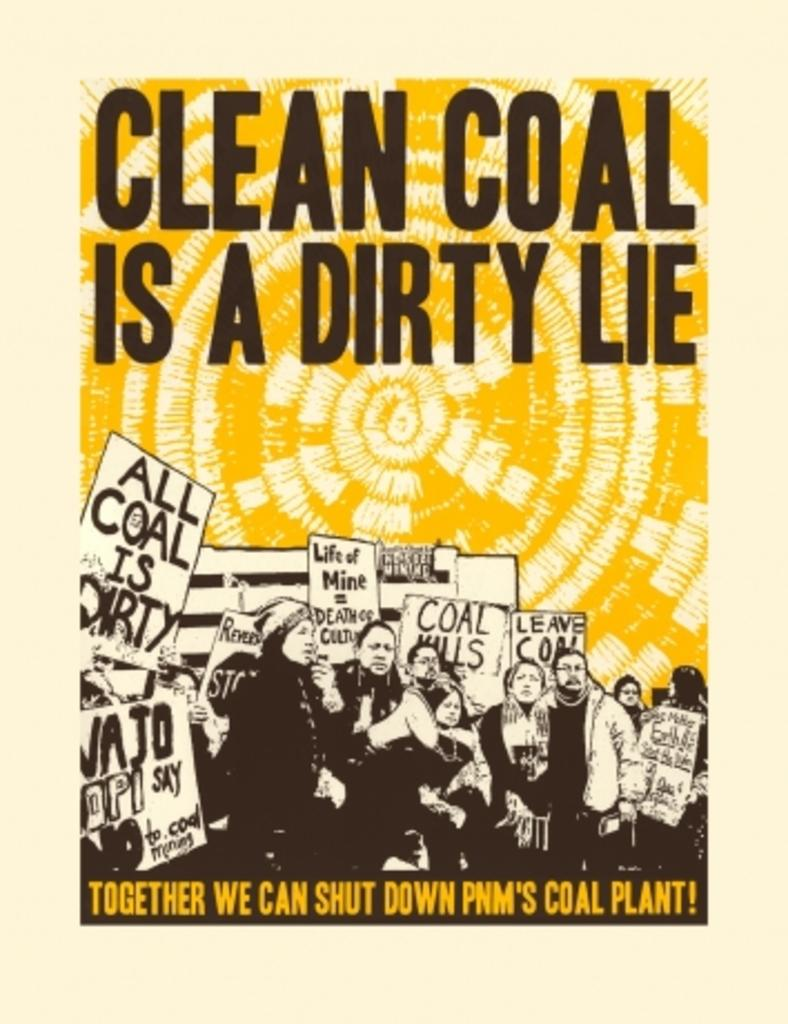<image>
Describe the image concisely. A poster says that clean coal is a dirty lie. 